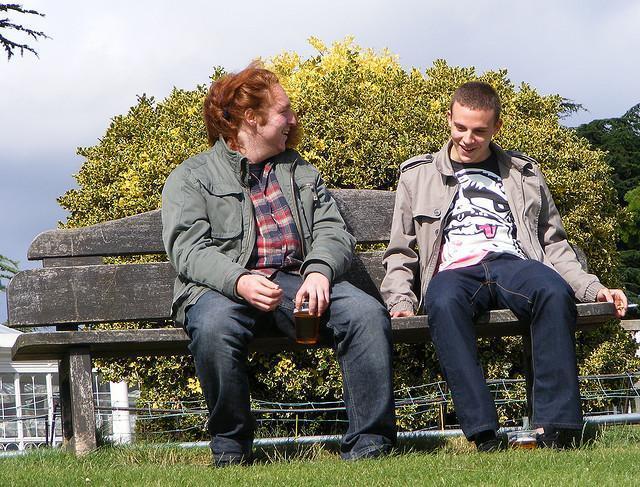How many people are there?
Give a very brief answer. 2. How many benches can be seen?
Give a very brief answer. 1. How many skis is the child wearing?
Give a very brief answer. 0. 